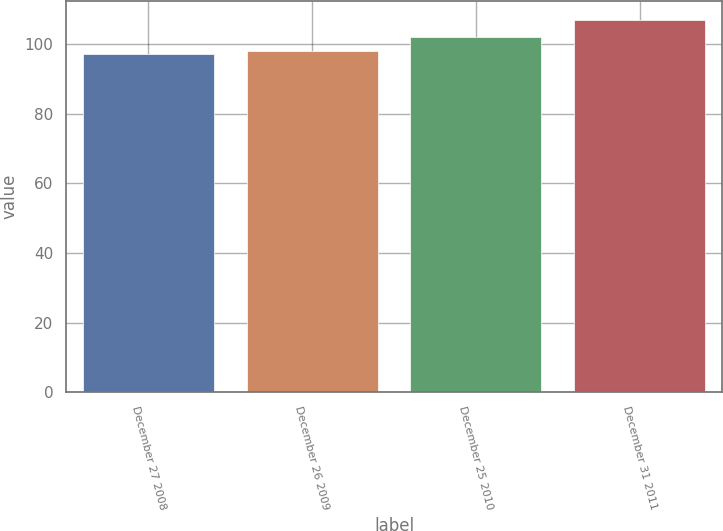<chart> <loc_0><loc_0><loc_500><loc_500><bar_chart><fcel>December 27 2008<fcel>December 26 2009<fcel>December 25 2010<fcel>December 31 2011<nl><fcel>97<fcel>98<fcel>102<fcel>107<nl></chart> 